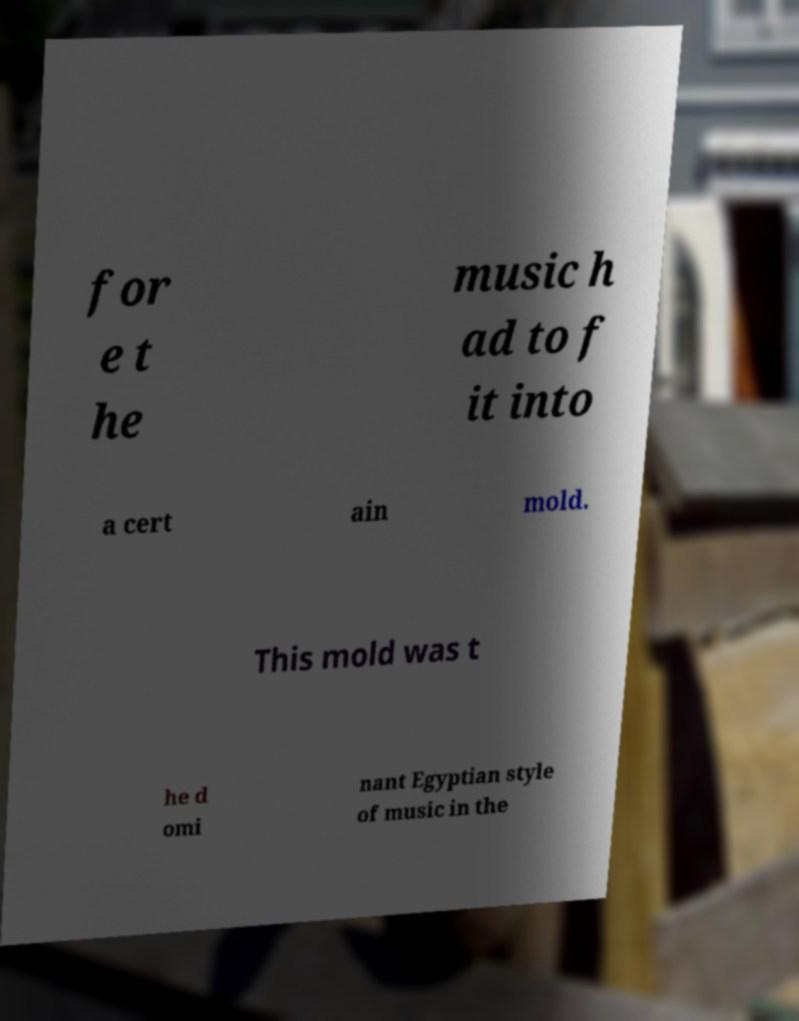What messages or text are displayed in this image? I need them in a readable, typed format. for e t he music h ad to f it into a cert ain mold. This mold was t he d omi nant Egyptian style of music in the 